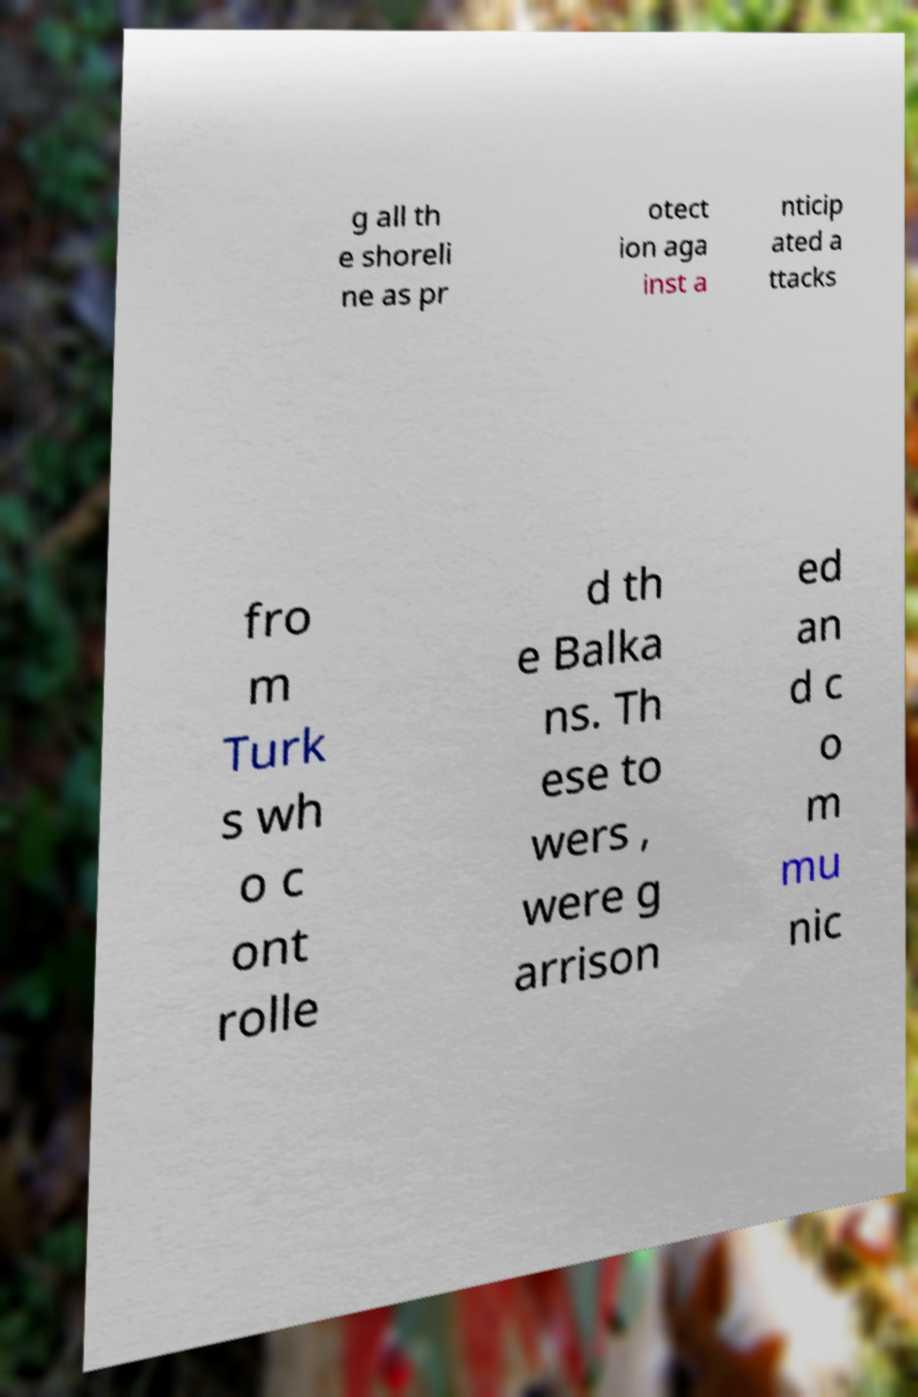Could you assist in decoding the text presented in this image and type it out clearly? g all th e shoreli ne as pr otect ion aga inst a nticip ated a ttacks fro m Turk s wh o c ont rolle d th e Balka ns. Th ese to wers , were g arrison ed an d c o m mu nic 